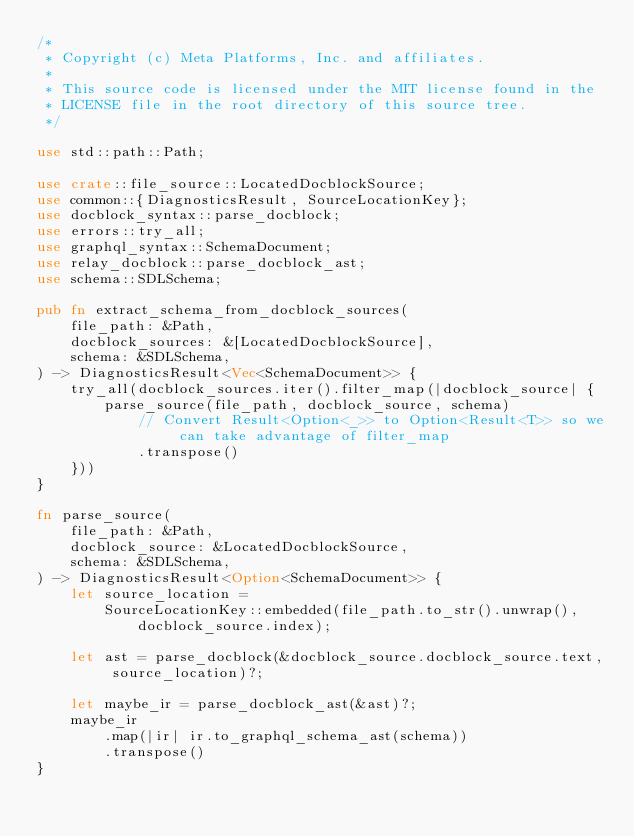Convert code to text. <code><loc_0><loc_0><loc_500><loc_500><_Rust_>/*
 * Copyright (c) Meta Platforms, Inc. and affiliates.
 *
 * This source code is licensed under the MIT license found in the
 * LICENSE file in the root directory of this source tree.
 */

use std::path::Path;

use crate::file_source::LocatedDocblockSource;
use common::{DiagnosticsResult, SourceLocationKey};
use docblock_syntax::parse_docblock;
use errors::try_all;
use graphql_syntax::SchemaDocument;
use relay_docblock::parse_docblock_ast;
use schema::SDLSchema;

pub fn extract_schema_from_docblock_sources(
    file_path: &Path,
    docblock_sources: &[LocatedDocblockSource],
    schema: &SDLSchema,
) -> DiagnosticsResult<Vec<SchemaDocument>> {
    try_all(docblock_sources.iter().filter_map(|docblock_source| {
        parse_source(file_path, docblock_source, schema)
            // Convert Result<Option<_>> to Option<Result<T>> so we can take advantage of filter_map
            .transpose()
    }))
}

fn parse_source(
    file_path: &Path,
    docblock_source: &LocatedDocblockSource,
    schema: &SDLSchema,
) -> DiagnosticsResult<Option<SchemaDocument>> {
    let source_location =
        SourceLocationKey::embedded(file_path.to_str().unwrap(), docblock_source.index);

    let ast = parse_docblock(&docblock_source.docblock_source.text, source_location)?;

    let maybe_ir = parse_docblock_ast(&ast)?;
    maybe_ir
        .map(|ir| ir.to_graphql_schema_ast(schema))
        .transpose()
}
</code> 